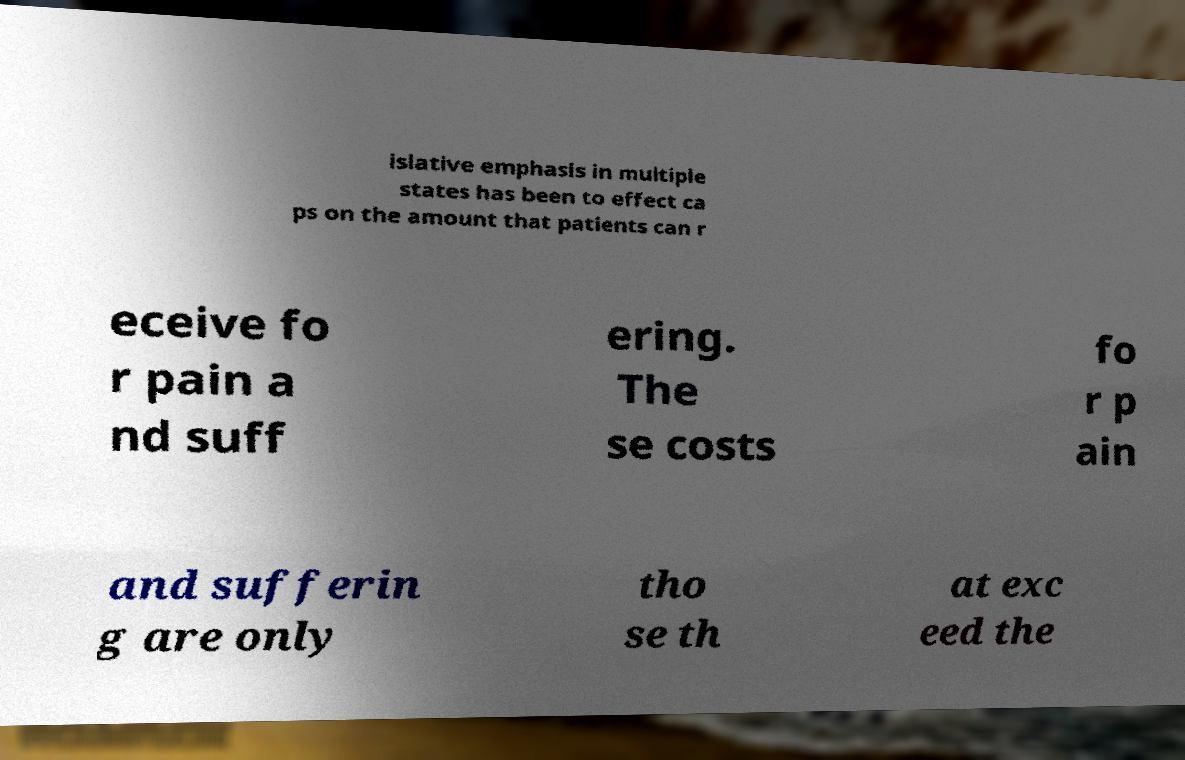Can you read and provide the text displayed in the image?This photo seems to have some interesting text. Can you extract and type it out for me? islative emphasis in multiple states has been to effect ca ps on the amount that patients can r eceive fo r pain a nd suff ering. The se costs fo r p ain and sufferin g are only tho se th at exc eed the 